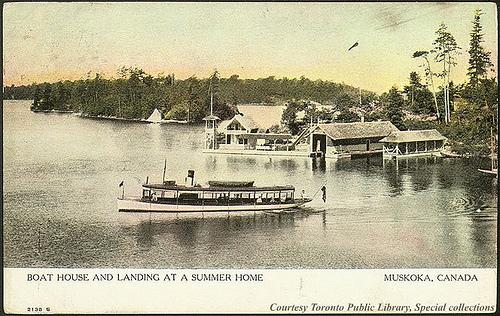What is the overall sentiment or atmosphere the image portrays? The image evokes a calming, serene, and picturesque atmosphere with a sense of tranquility and beauty in nature. How many boats are there on the water and with what details? There are multiple boats, including a white boat with a flag, a long boat causing water ripples, a sailboat and a rowboat on top of another boat. Identify the smaller details in the image, such as objects on the boats and specific features of the buildings. Details include a flag hanging from one boat, rowboat on top of another boat, smoke stack of the boat, a window on the boathouse, an observation tower, and a bird flying in the sky. Mention the main colors appearing in the image and their associations. White is associated with the boat and writing, blue with the sky, green with the leaves and trees, and black with the lettering. Provide a short description of the scene depicted in the image. A boat is on a calm river surrounded by trees, with a building on the riverbank and a bird flying in the sky above. What types of objects can be seen in the water? Boats, a dock, piers, and ripples can be seen in the water. Describe the interaction between the boat and its environment. The boat creates ripples in the calm water as it moves, while it is surrounded by trees, buildings and piers on the riverbank. Count the number of buildings and flying birds visible in the image. There is one flying bird, and at least four buildings can be seen. Explain the importance of trees in the image and their relationship to the water. The trees provide a scenic backdrop for the river, enhancing the image's natural appeal and creating a sense of harmony between water and land. What can you infer from the peacefulness of the scene? The image conveys a sense of tranquility, relaxation, and connection with nature. Are there any distorted areas or artifacts in this image? No distorted areas or artifacts found. Is there any visible smoke coming from smokestack of the boat? There are no captions describing visible smoke from the smokestack of the boat. Therefore, suggesting that there is visible smoke would be misleading. Does the bird have a red-colored body? The bird's color is not mentioned in any of the captions. Therefore, suggesting that the bird has a specific color like red would be misleading. Identify the interactions of the objects in the image. Boat in the water creating ripples, bird flying above the river, flag hanging from the back of the boat, trees and buildings by the river. Which object does "the water is calm" refer to? water body What type of body of water is it? It is a calm river. Does the image showcase a tranquil or chaotic environment? Tranquil environment. Which object among these best describes the water in the image: a) rough sea b) calm lake c) gentle stream? b) calm lake Are there any flower decorations on the pier by the river? The captions only mention "a pier on the river" and do not describe any flower decorations. So, suggesting that there are flower decorations on the pier would be misleading. Are there multiple flags on the back of the boat? Only one flag is mentioned in the captions, stating that "a flag hanging from the back of the boat" and "flag on back of boat". Suggesting multiple flags would be misleading. Segment the different areas of the image. sky, woods, water, boat, buildings, and trees Is there any visible text in the image? Yes, there is black lettering on a white card. Is the building surrounded by tall skyscrapers? There is no mention of any skyscrapers in the captions, only a single building and a boathouse are mentioned. So, suggesting that the building is surrounded by tall skyscrapers would be misleading. Describe the appearance of the leaves mentioned in the image. The leaves are green in color. Analyze the relationship between the boat and the water in the image. The boat is on the water, causing ripples. Detect any anomaly in the image. No anomalies detected. Are there any objects in the image that are inconsistent with the rest of the scene? No inconsistencies found. How is the quality of the image in terms of details and sharpness? high-quality with clear and sharp details What emotions does the image evoke? calmness and serenity Is there a group of people standing near the boat? None of the captions describes the presence of people in the image. So, mentioning a group of people standing near the boat would be wrong and misleading. Find objects in the sky of the image. bird, clouds Describe the scene depicted in this image. A boat on a calm river with trees, buildings, and a boathouse nearby, a bird in the sky, and black writing on a white card. What color is the boat in the image? The boat is white. List down all the objects found in this image. boat, water, building, tree, writing, sky, roof, boathouses, bird, sailboat, flag, observation tower, smoke stack, woods, pier 